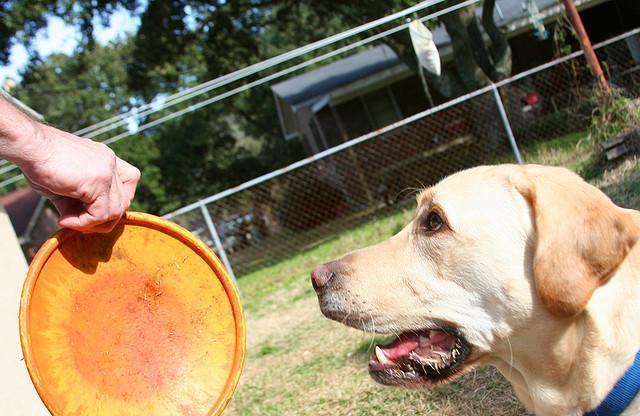How many dogs do you see?
Give a very brief answer. 1. 